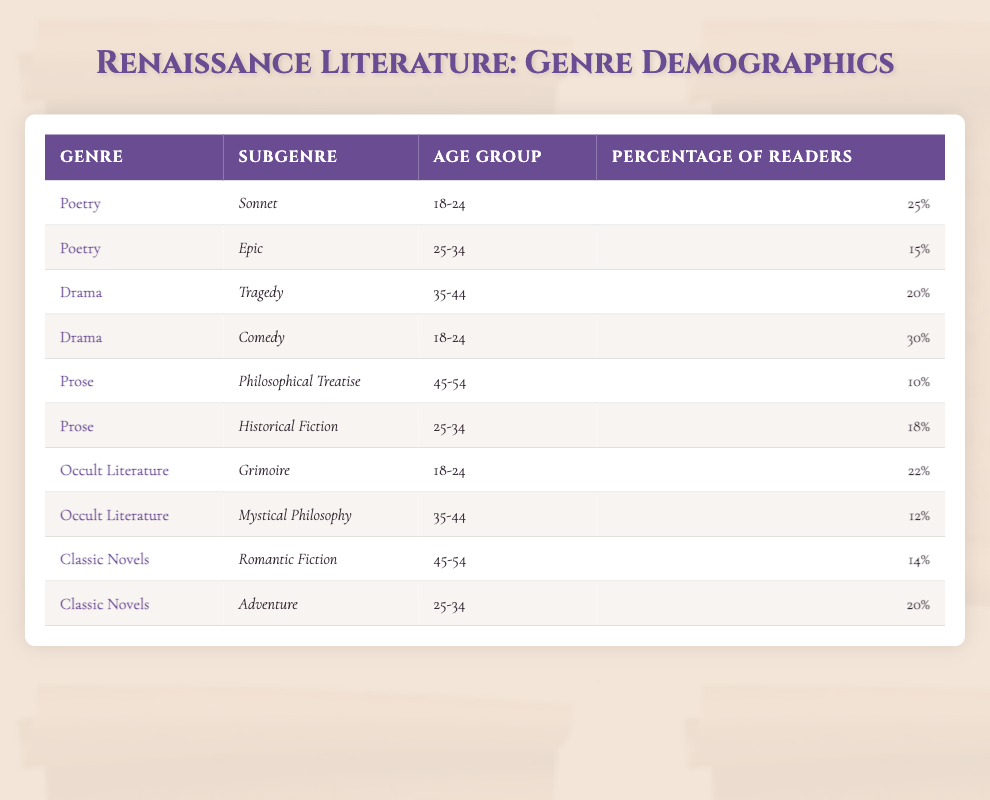What age group shows the highest percentage of readers for Comedy under Drama? Looking at the table, the highest percentage for the Comedy subgenre under the Drama genre is 30%, which corresponds to the age group 18-24.
Answer: 18-24 What percentage of readers in the age group 25-34 prefer Epic poetry? The table shows that the percentage of readers aged 25-34 who prefer Epic poetry is 15%.
Answer: 15% Is the percentage of readers for Grimoire literature in the age group 18-24 higher than that for Tragedy in the age group 35-44? The Grimoire literature has a percentage of 22% for the age group 18-24, while Tragedy has a percentage of 20% for the age group 35-44. Since 22% is higher than 20%, the answer is yes.
Answer: Yes What is the combined percentage of readers for Historical Fiction and Adventure in the age group 25-34? The percentage of readers for Historical Fiction in the age group 25-34 is 18%, and for Adventure, it is 20%. Adding them together gives 18 + 20 = 38%.
Answer: 38% Which genre has a lower percentage of readers in the age group 45-54: Prose (Philosophical Treatise) or Classic Novels (Romantic Fiction)? In the table, the Prose (Philosophical Treatise) has a percentage of 10% and Classic Novels (Romantic Fiction) has a percentage of 14% for the age group 45-54. Therefore, Prose has a lower percentage.
Answer: Prose (Philosophical Treatise) 